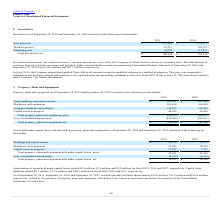According to Plexus's financial document, What was the Amortization of assets held under capital leases in 2017? According to the financial document, 3.0 (in millions). The relevant text states: "al leases totaled $3.8 million, $3.4 million and $3.0 million for fiscal 2019, 2018 and 2017, respectively. Capital lease additions totaled $6.7 million,..." Also, What was the amount of capital assets in progress in 2018? According to the financial document, 7,747 (in thousands). The relevant text states: "Capital assets in progress 11,831 7,747..." Also, What was the net Total property, plant and equipment held under capital leases in 2019? According to the financial document, 39,079 (in thousands). The relevant text states: "nt and equipment held under capital leases, net $ 39,079 $ 36,336..." Also, How many years did the Capital assets in progress exceed $10,000 thousand? Based on the analysis, there are 1 instances. The counting process: 2019. Also, can you calculate: What was the change in the gross Total property, plant and equipment held under capital leases between 2018 and 2019? Based on the calculation: 47,841-42,459, the result is 5382 (in thousands). This is based on the information: "nt and equipment held under capital leases, gross 47,841 42,459 equipment held under capital leases, gross 47,841 42,459..." The key data points involved are: 42,459, 47,841. Also, can you calculate: What was the percentage change in the accumulated amortization between 2018 and 2019? To answer this question, I need to perform calculations using the financial data. The calculation is: (-8,762-(-6,123))/-6,123, which equals 43.1 (percentage). This is based on the information: "Less: accumulated amortization (8,762) (6,123) Less: accumulated amortization (8,762) (6,123)..." The key data points involved are: 6,123, 8,762. 